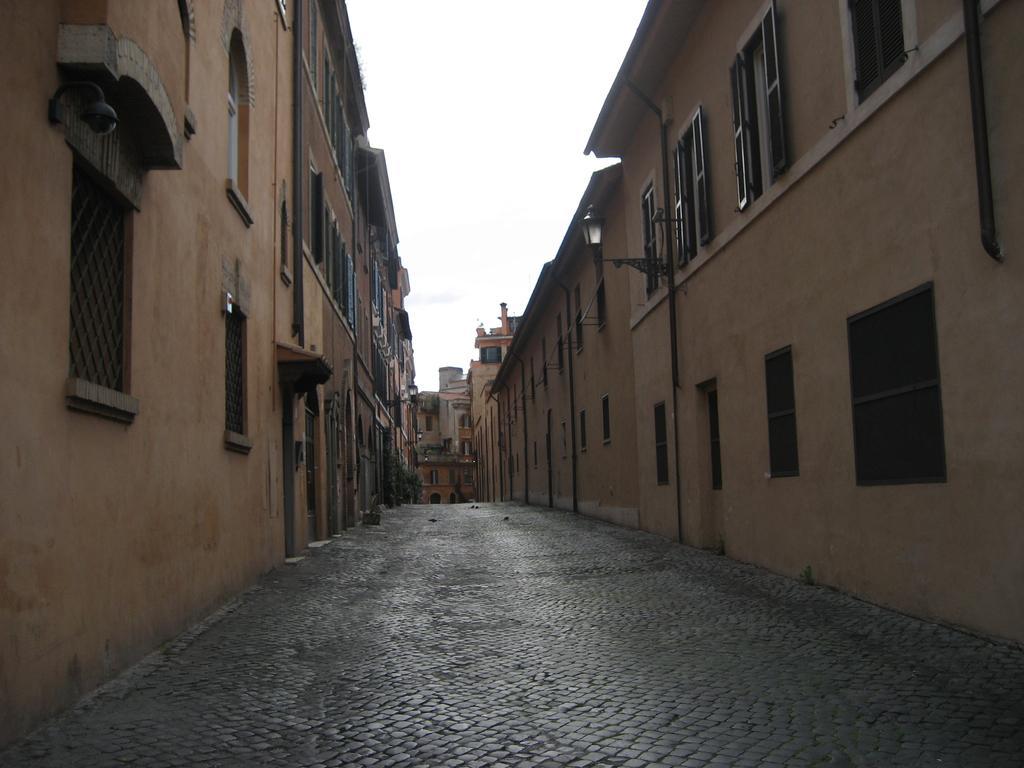How would you summarize this image in a sentence or two? In this image we can see many buildings and they are having many windows. There are few lights in the image. We can see the sky in the image. 